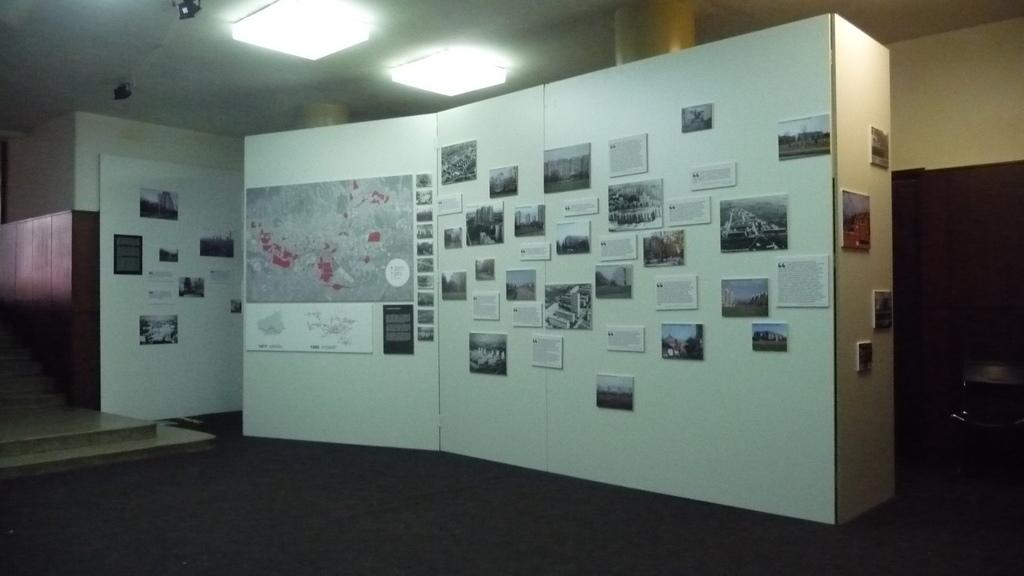What is the color of the wall in the image? The wall in the image is white. What is displayed on the white wall? A map, pictures, and posters are present on the wall. What type of lighting is present in the image? Lights are attached to the ceiling. What type of furniture is in the image? There is a chair in the image. Where is the shelf located in the image? There is no shelf present in the image. What type of arithmetic problem is being solved on the wall? There is no arithmetic problem present in the image. 